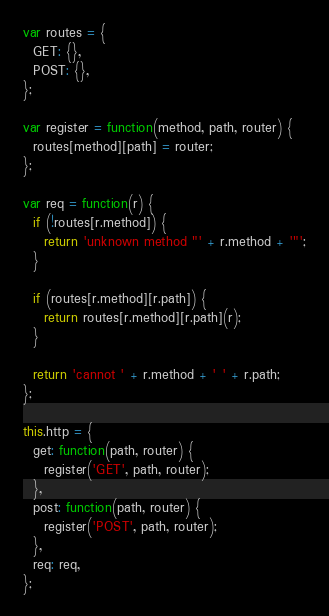<code> <loc_0><loc_0><loc_500><loc_500><_JavaScript_>var routes = {
  GET: {},
  POST: {},
};

var register = function(method, path, router) {
  routes[method][path] = router;
};

var req = function(r) {
  if (!routes[r.method]) {
    return 'unknown method "' + r.method + '"';
  }

  if (routes[r.method][r.path]) {
    return routes[r.method][r.path](r);
  }

  return 'cannot ' + r.method + ' ' + r.path;
};

this.http = {
  get: function(path, router) {
    register('GET', path, router);
  },
  post: function(path, router) {
    register('POST', path, router);
  },
  req: req,
};
</code> 